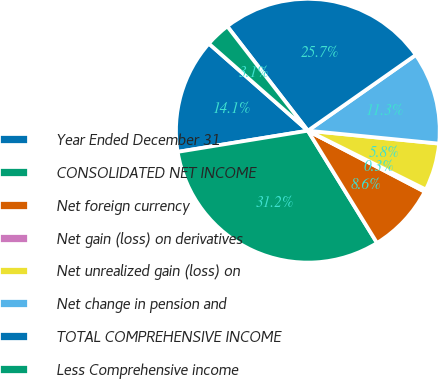Convert chart to OTSL. <chart><loc_0><loc_0><loc_500><loc_500><pie_chart><fcel>Year Ended December 31<fcel>CONSOLIDATED NET INCOME<fcel>Net foreign currency<fcel>Net gain (loss) on derivatives<fcel>Net unrealized gain (loss) on<fcel>Net change in pension and<fcel>TOTAL COMPREHENSIVE INCOME<fcel>Less Comprehensive income<nl><fcel>14.05%<fcel>31.22%<fcel>8.55%<fcel>0.3%<fcel>5.8%<fcel>11.3%<fcel>25.72%<fcel>3.05%<nl></chart> 